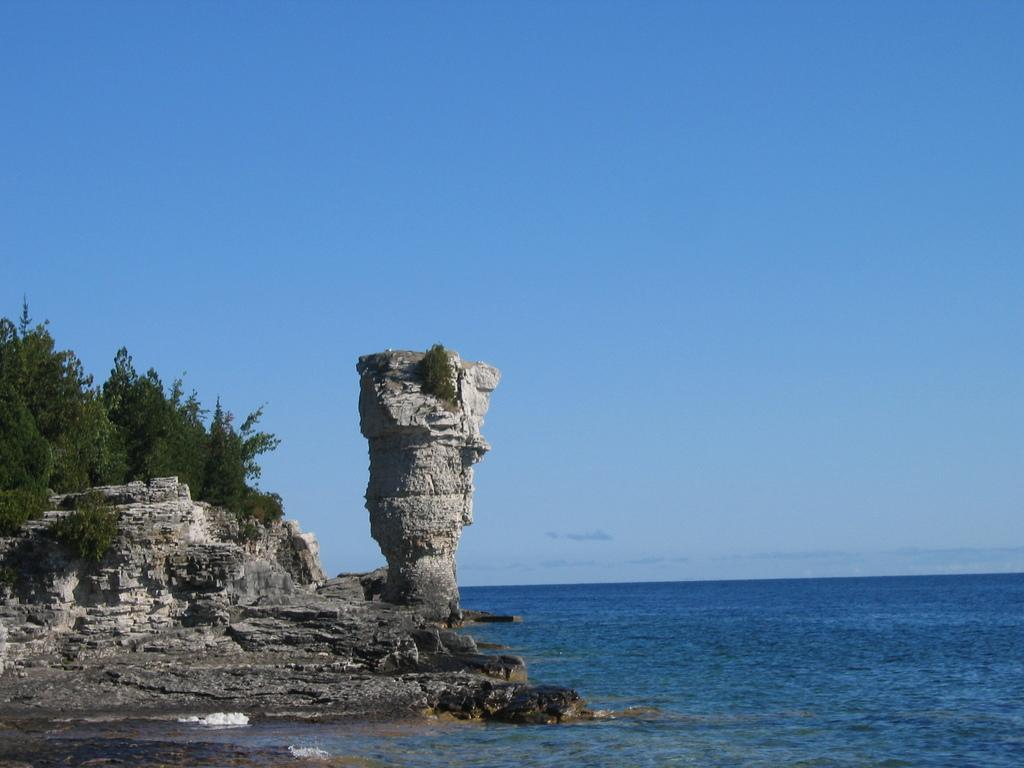What natural feature can be seen in the image? There is the sea in the image. What man-made structure is depicted in the image? There is a collapsed monument in the image. What type of plant is present in the image? There is a tree in the image. What is visible above the sea and monument in the image? The sky is visible in the image. What type of tail can be seen on the collapsed monument in the image? There is no tail present on the collapsed monument in the image. What form of love is depicted in the image? There is no depiction of love in the image; it features the sea, a collapsed monument, a tree, and the sky. 